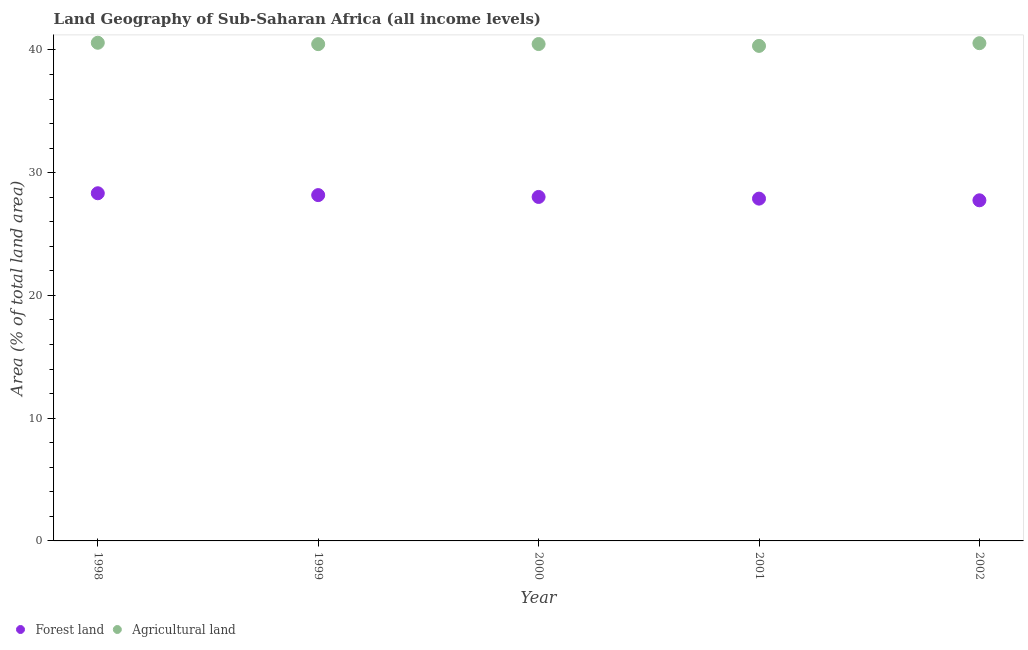How many different coloured dotlines are there?
Provide a succinct answer. 2. Is the number of dotlines equal to the number of legend labels?
Make the answer very short. Yes. What is the percentage of land area under forests in 2001?
Provide a succinct answer. 27.89. Across all years, what is the maximum percentage of land area under forests?
Your answer should be very brief. 28.33. Across all years, what is the minimum percentage of land area under agriculture?
Your answer should be compact. 40.33. In which year was the percentage of land area under forests maximum?
Provide a short and direct response. 1998. In which year was the percentage of land area under forests minimum?
Give a very brief answer. 2002. What is the total percentage of land area under agriculture in the graph?
Your answer should be compact. 202.43. What is the difference between the percentage of land area under forests in 1998 and that in 1999?
Give a very brief answer. 0.15. What is the difference between the percentage of land area under forests in 2002 and the percentage of land area under agriculture in 2000?
Your answer should be compact. -12.73. What is the average percentage of land area under forests per year?
Your answer should be very brief. 28.03. In the year 1999, what is the difference between the percentage of land area under forests and percentage of land area under agriculture?
Provide a short and direct response. -12.3. What is the ratio of the percentage of land area under forests in 2000 to that in 2001?
Offer a terse response. 1. What is the difference between the highest and the second highest percentage of land area under agriculture?
Provide a short and direct response. 0.04. What is the difference between the highest and the lowest percentage of land area under forests?
Ensure brevity in your answer.  0.57. In how many years, is the percentage of land area under agriculture greater than the average percentage of land area under agriculture taken over all years?
Offer a terse response. 2. Is the sum of the percentage of land area under forests in 1998 and 2001 greater than the maximum percentage of land area under agriculture across all years?
Provide a short and direct response. Yes. Does the percentage of land area under agriculture monotonically increase over the years?
Offer a terse response. No. Is the percentage of land area under forests strictly greater than the percentage of land area under agriculture over the years?
Keep it short and to the point. No. How many dotlines are there?
Offer a very short reply. 2. How many years are there in the graph?
Your response must be concise. 5. Are the values on the major ticks of Y-axis written in scientific E-notation?
Ensure brevity in your answer.  No. How are the legend labels stacked?
Give a very brief answer. Horizontal. What is the title of the graph?
Your response must be concise. Land Geography of Sub-Saharan Africa (all income levels). What is the label or title of the X-axis?
Make the answer very short. Year. What is the label or title of the Y-axis?
Give a very brief answer. Area (% of total land area). What is the Area (% of total land area) in Forest land in 1998?
Keep it short and to the point. 28.33. What is the Area (% of total land area) in Agricultural land in 1998?
Offer a terse response. 40.59. What is the Area (% of total land area) in Forest land in 1999?
Your answer should be very brief. 28.18. What is the Area (% of total land area) of Agricultural land in 1999?
Offer a very short reply. 40.48. What is the Area (% of total land area) of Forest land in 2000?
Make the answer very short. 28.02. What is the Area (% of total land area) in Agricultural land in 2000?
Offer a very short reply. 40.48. What is the Area (% of total land area) of Forest land in 2001?
Keep it short and to the point. 27.89. What is the Area (% of total land area) of Agricultural land in 2001?
Offer a very short reply. 40.33. What is the Area (% of total land area) of Forest land in 2002?
Keep it short and to the point. 27.75. What is the Area (% of total land area) of Agricultural land in 2002?
Provide a short and direct response. 40.55. Across all years, what is the maximum Area (% of total land area) in Forest land?
Provide a succinct answer. 28.33. Across all years, what is the maximum Area (% of total land area) in Agricultural land?
Ensure brevity in your answer.  40.59. Across all years, what is the minimum Area (% of total land area) in Forest land?
Keep it short and to the point. 27.75. Across all years, what is the minimum Area (% of total land area) in Agricultural land?
Offer a very short reply. 40.33. What is the total Area (% of total land area) of Forest land in the graph?
Make the answer very short. 140.17. What is the total Area (% of total land area) in Agricultural land in the graph?
Your response must be concise. 202.43. What is the difference between the Area (% of total land area) of Forest land in 1998 and that in 1999?
Make the answer very short. 0.15. What is the difference between the Area (% of total land area) of Agricultural land in 1998 and that in 1999?
Provide a succinct answer. 0.11. What is the difference between the Area (% of total land area) in Forest land in 1998 and that in 2000?
Keep it short and to the point. 0.3. What is the difference between the Area (% of total land area) in Agricultural land in 1998 and that in 2000?
Ensure brevity in your answer.  0.11. What is the difference between the Area (% of total land area) in Forest land in 1998 and that in 2001?
Your answer should be very brief. 0.44. What is the difference between the Area (% of total land area) in Agricultural land in 1998 and that in 2001?
Offer a terse response. 0.26. What is the difference between the Area (% of total land area) in Forest land in 1998 and that in 2002?
Give a very brief answer. 0.57. What is the difference between the Area (% of total land area) in Agricultural land in 1998 and that in 2002?
Ensure brevity in your answer.  0.04. What is the difference between the Area (% of total land area) of Forest land in 1999 and that in 2000?
Your answer should be compact. 0.15. What is the difference between the Area (% of total land area) of Agricultural land in 1999 and that in 2000?
Your answer should be compact. -0.01. What is the difference between the Area (% of total land area) in Forest land in 1999 and that in 2001?
Your response must be concise. 0.29. What is the difference between the Area (% of total land area) of Agricultural land in 1999 and that in 2001?
Give a very brief answer. 0.14. What is the difference between the Area (% of total land area) in Forest land in 1999 and that in 2002?
Your answer should be very brief. 0.42. What is the difference between the Area (% of total land area) in Agricultural land in 1999 and that in 2002?
Provide a succinct answer. -0.08. What is the difference between the Area (% of total land area) in Forest land in 2000 and that in 2001?
Make the answer very short. 0.14. What is the difference between the Area (% of total land area) of Agricultural land in 2000 and that in 2001?
Your answer should be compact. 0.15. What is the difference between the Area (% of total land area) of Forest land in 2000 and that in 2002?
Your answer should be very brief. 0.27. What is the difference between the Area (% of total land area) of Agricultural land in 2000 and that in 2002?
Your response must be concise. -0.07. What is the difference between the Area (% of total land area) of Forest land in 2001 and that in 2002?
Your answer should be compact. 0.14. What is the difference between the Area (% of total land area) in Agricultural land in 2001 and that in 2002?
Give a very brief answer. -0.22. What is the difference between the Area (% of total land area) in Forest land in 1998 and the Area (% of total land area) in Agricultural land in 1999?
Your answer should be very brief. -12.15. What is the difference between the Area (% of total land area) of Forest land in 1998 and the Area (% of total land area) of Agricultural land in 2000?
Give a very brief answer. -12.16. What is the difference between the Area (% of total land area) of Forest land in 1998 and the Area (% of total land area) of Agricultural land in 2001?
Provide a succinct answer. -12.01. What is the difference between the Area (% of total land area) in Forest land in 1998 and the Area (% of total land area) in Agricultural land in 2002?
Offer a terse response. -12.23. What is the difference between the Area (% of total land area) in Forest land in 1999 and the Area (% of total land area) in Agricultural land in 2000?
Keep it short and to the point. -12.31. What is the difference between the Area (% of total land area) in Forest land in 1999 and the Area (% of total land area) in Agricultural land in 2001?
Your answer should be very brief. -12.16. What is the difference between the Area (% of total land area) in Forest land in 1999 and the Area (% of total land area) in Agricultural land in 2002?
Keep it short and to the point. -12.38. What is the difference between the Area (% of total land area) of Forest land in 2000 and the Area (% of total land area) of Agricultural land in 2001?
Keep it short and to the point. -12.31. What is the difference between the Area (% of total land area) in Forest land in 2000 and the Area (% of total land area) in Agricultural land in 2002?
Ensure brevity in your answer.  -12.53. What is the difference between the Area (% of total land area) of Forest land in 2001 and the Area (% of total land area) of Agricultural land in 2002?
Keep it short and to the point. -12.66. What is the average Area (% of total land area) in Forest land per year?
Make the answer very short. 28.03. What is the average Area (% of total land area) in Agricultural land per year?
Offer a very short reply. 40.49. In the year 1998, what is the difference between the Area (% of total land area) of Forest land and Area (% of total land area) of Agricultural land?
Your answer should be compact. -12.26. In the year 1999, what is the difference between the Area (% of total land area) in Forest land and Area (% of total land area) in Agricultural land?
Provide a short and direct response. -12.3. In the year 2000, what is the difference between the Area (% of total land area) of Forest land and Area (% of total land area) of Agricultural land?
Give a very brief answer. -12.46. In the year 2001, what is the difference between the Area (% of total land area) of Forest land and Area (% of total land area) of Agricultural land?
Keep it short and to the point. -12.44. In the year 2002, what is the difference between the Area (% of total land area) of Forest land and Area (% of total land area) of Agricultural land?
Keep it short and to the point. -12.8. What is the ratio of the Area (% of total land area) of Forest land in 1998 to that in 2000?
Provide a succinct answer. 1.01. What is the ratio of the Area (% of total land area) of Agricultural land in 1998 to that in 2000?
Offer a terse response. 1. What is the ratio of the Area (% of total land area) of Forest land in 1998 to that in 2001?
Provide a short and direct response. 1.02. What is the ratio of the Area (% of total land area) of Agricultural land in 1998 to that in 2001?
Give a very brief answer. 1.01. What is the ratio of the Area (% of total land area) in Forest land in 1998 to that in 2002?
Keep it short and to the point. 1.02. What is the ratio of the Area (% of total land area) of Forest land in 1999 to that in 2000?
Ensure brevity in your answer.  1.01. What is the ratio of the Area (% of total land area) of Agricultural land in 1999 to that in 2000?
Your response must be concise. 1. What is the ratio of the Area (% of total land area) in Forest land in 1999 to that in 2001?
Give a very brief answer. 1.01. What is the ratio of the Area (% of total land area) in Agricultural land in 1999 to that in 2001?
Give a very brief answer. 1. What is the ratio of the Area (% of total land area) in Forest land in 1999 to that in 2002?
Offer a very short reply. 1.02. What is the ratio of the Area (% of total land area) in Agricultural land in 2000 to that in 2001?
Offer a terse response. 1. What is the ratio of the Area (% of total land area) in Forest land in 2000 to that in 2002?
Make the answer very short. 1.01. What is the ratio of the Area (% of total land area) in Agricultural land in 2001 to that in 2002?
Offer a very short reply. 0.99. What is the difference between the highest and the second highest Area (% of total land area) in Forest land?
Provide a short and direct response. 0.15. What is the difference between the highest and the second highest Area (% of total land area) in Agricultural land?
Make the answer very short. 0.04. What is the difference between the highest and the lowest Area (% of total land area) of Forest land?
Make the answer very short. 0.57. What is the difference between the highest and the lowest Area (% of total land area) of Agricultural land?
Your answer should be very brief. 0.26. 